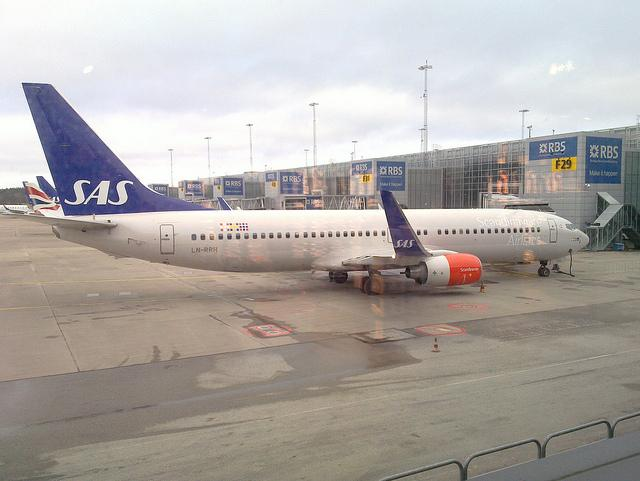What country is served by this airline?

Choices:
A) china
B) egypt
C) sweden
D) netherlands sweden 